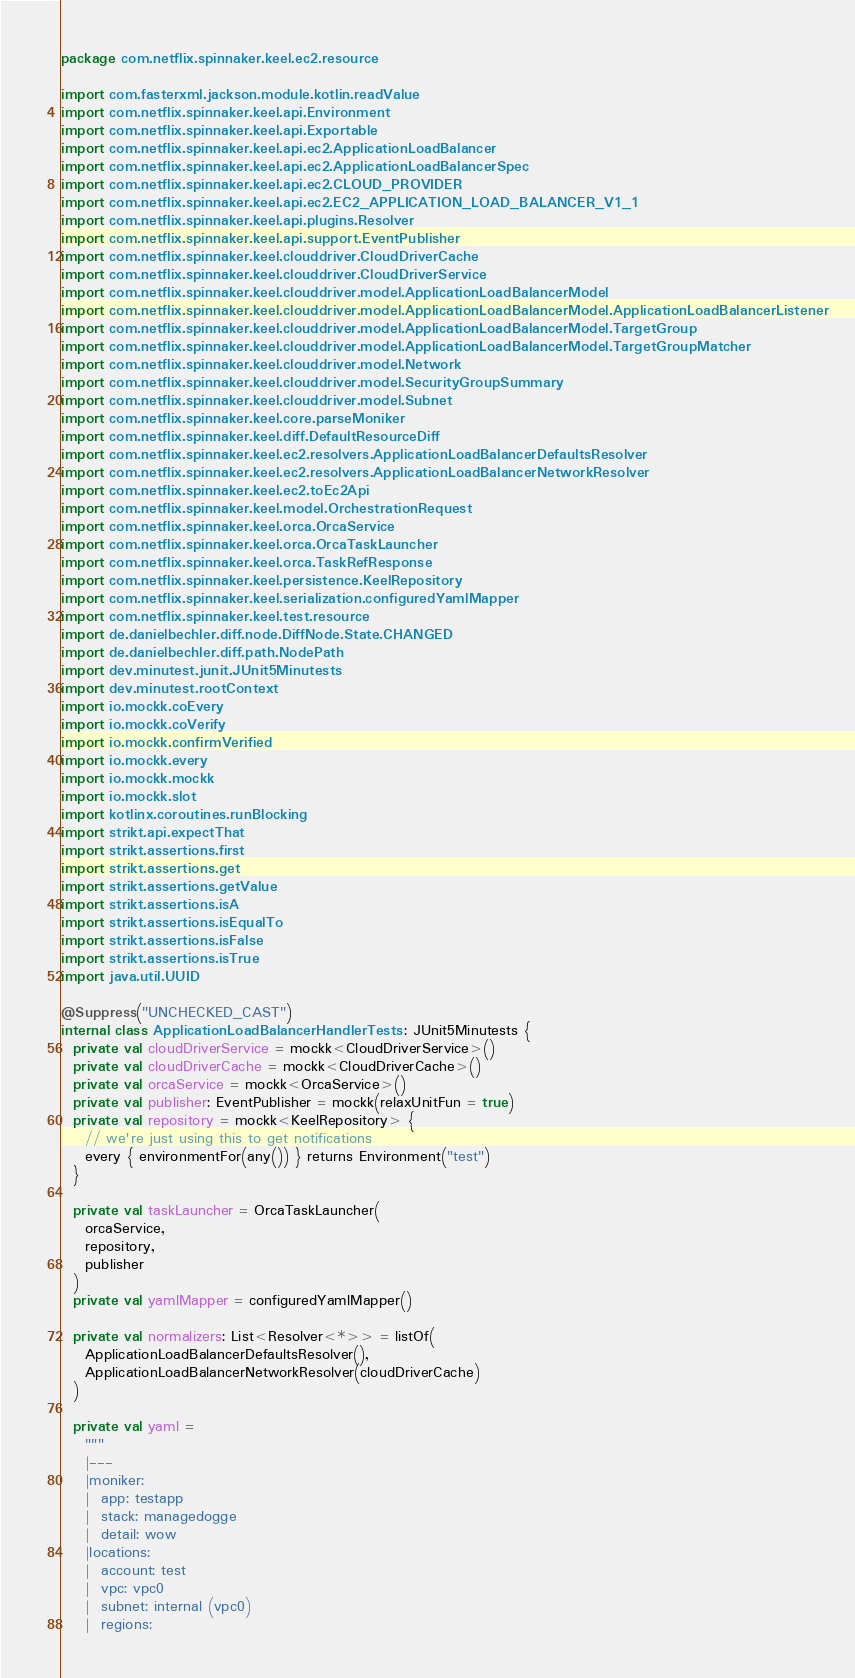Convert code to text. <code><loc_0><loc_0><loc_500><loc_500><_Kotlin_>package com.netflix.spinnaker.keel.ec2.resource

import com.fasterxml.jackson.module.kotlin.readValue
import com.netflix.spinnaker.keel.api.Environment
import com.netflix.spinnaker.keel.api.Exportable
import com.netflix.spinnaker.keel.api.ec2.ApplicationLoadBalancer
import com.netflix.spinnaker.keel.api.ec2.ApplicationLoadBalancerSpec
import com.netflix.spinnaker.keel.api.ec2.CLOUD_PROVIDER
import com.netflix.spinnaker.keel.api.ec2.EC2_APPLICATION_LOAD_BALANCER_V1_1
import com.netflix.spinnaker.keel.api.plugins.Resolver
import com.netflix.spinnaker.keel.api.support.EventPublisher
import com.netflix.spinnaker.keel.clouddriver.CloudDriverCache
import com.netflix.spinnaker.keel.clouddriver.CloudDriverService
import com.netflix.spinnaker.keel.clouddriver.model.ApplicationLoadBalancerModel
import com.netflix.spinnaker.keel.clouddriver.model.ApplicationLoadBalancerModel.ApplicationLoadBalancerListener
import com.netflix.spinnaker.keel.clouddriver.model.ApplicationLoadBalancerModel.TargetGroup
import com.netflix.spinnaker.keel.clouddriver.model.ApplicationLoadBalancerModel.TargetGroupMatcher
import com.netflix.spinnaker.keel.clouddriver.model.Network
import com.netflix.spinnaker.keel.clouddriver.model.SecurityGroupSummary
import com.netflix.spinnaker.keel.clouddriver.model.Subnet
import com.netflix.spinnaker.keel.core.parseMoniker
import com.netflix.spinnaker.keel.diff.DefaultResourceDiff
import com.netflix.spinnaker.keel.ec2.resolvers.ApplicationLoadBalancerDefaultsResolver
import com.netflix.spinnaker.keel.ec2.resolvers.ApplicationLoadBalancerNetworkResolver
import com.netflix.spinnaker.keel.ec2.toEc2Api
import com.netflix.spinnaker.keel.model.OrchestrationRequest
import com.netflix.spinnaker.keel.orca.OrcaService
import com.netflix.spinnaker.keel.orca.OrcaTaskLauncher
import com.netflix.spinnaker.keel.orca.TaskRefResponse
import com.netflix.spinnaker.keel.persistence.KeelRepository
import com.netflix.spinnaker.keel.serialization.configuredYamlMapper
import com.netflix.spinnaker.keel.test.resource
import de.danielbechler.diff.node.DiffNode.State.CHANGED
import de.danielbechler.diff.path.NodePath
import dev.minutest.junit.JUnit5Minutests
import dev.minutest.rootContext
import io.mockk.coEvery
import io.mockk.coVerify
import io.mockk.confirmVerified
import io.mockk.every
import io.mockk.mockk
import io.mockk.slot
import kotlinx.coroutines.runBlocking
import strikt.api.expectThat
import strikt.assertions.first
import strikt.assertions.get
import strikt.assertions.getValue
import strikt.assertions.isA
import strikt.assertions.isEqualTo
import strikt.assertions.isFalse
import strikt.assertions.isTrue
import java.util.UUID

@Suppress("UNCHECKED_CAST")
internal class ApplicationLoadBalancerHandlerTests : JUnit5Minutests {
  private val cloudDriverService = mockk<CloudDriverService>()
  private val cloudDriverCache = mockk<CloudDriverCache>()
  private val orcaService = mockk<OrcaService>()
  private val publisher: EventPublisher = mockk(relaxUnitFun = true)
  private val repository = mockk<KeelRepository> {
    // we're just using this to get notifications
    every { environmentFor(any()) } returns Environment("test")
  }

  private val taskLauncher = OrcaTaskLauncher(
    orcaService,
    repository,
    publisher
  )
  private val yamlMapper = configuredYamlMapper()

  private val normalizers: List<Resolver<*>> = listOf(
    ApplicationLoadBalancerDefaultsResolver(),
    ApplicationLoadBalancerNetworkResolver(cloudDriverCache)
  )

  private val yaml =
    """
    |---
    |moniker:
    |  app: testapp
    |  stack: managedogge
    |  detail: wow
    |locations:
    |  account: test
    |  vpc: vpc0
    |  subnet: internal (vpc0)
    |  regions:</code> 